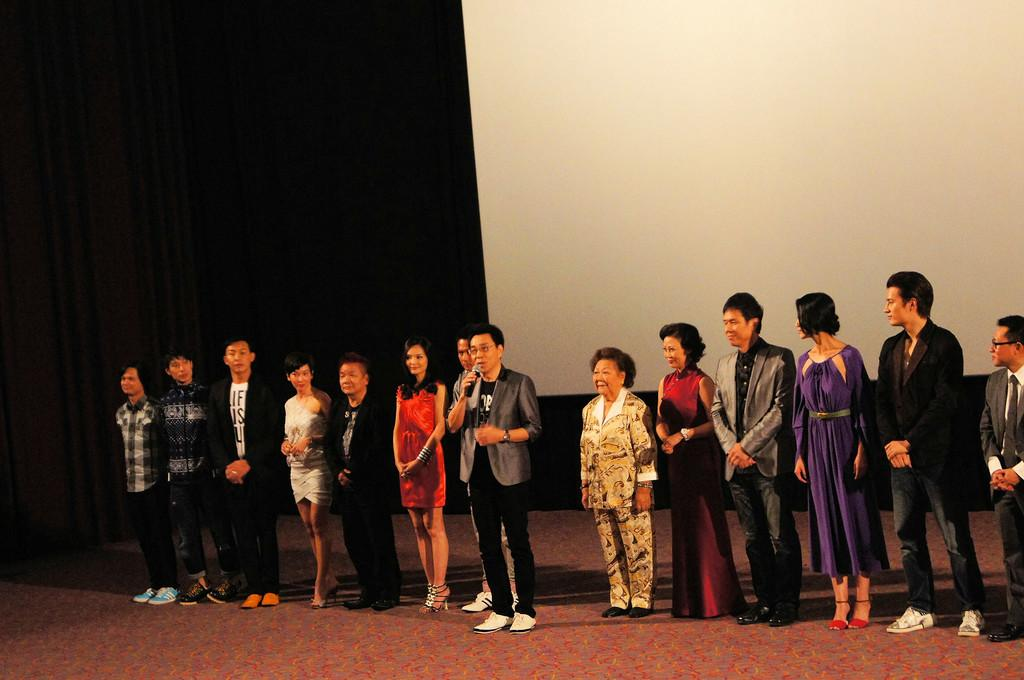What is happening in the image? There is a group of people in the image, and they are standing on a stage. What is the person with the microphone doing? The person with the microphone is speaking. What color are the balls being juggled by the person on the stage? There are no balls being juggled in the image; the person with the microphone is speaking. 